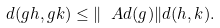<formula> <loc_0><loc_0><loc_500><loc_500>d ( g h , g k ) \leq \| \ A d ( g ) \| d ( h , k ) .</formula> 